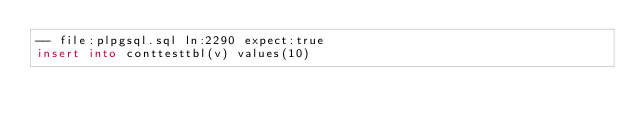<code> <loc_0><loc_0><loc_500><loc_500><_SQL_>-- file:plpgsql.sql ln:2290 expect:true
insert into conttesttbl(v) values(10)
</code> 